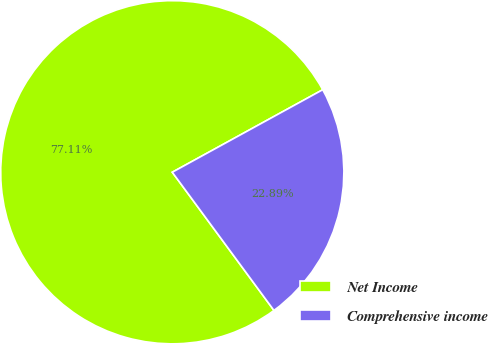Convert chart. <chart><loc_0><loc_0><loc_500><loc_500><pie_chart><fcel>Net Income<fcel>Comprehensive income<nl><fcel>77.11%<fcel>22.89%<nl></chart> 